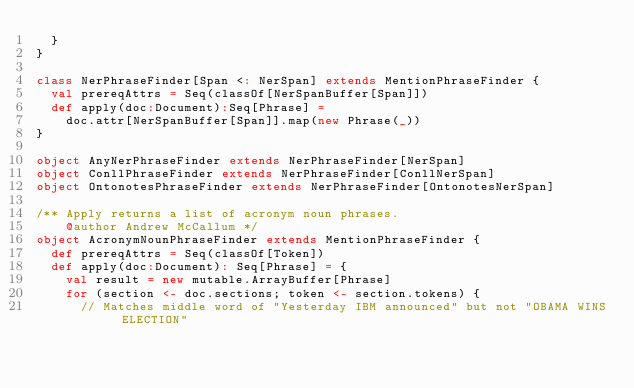<code> <loc_0><loc_0><loc_500><loc_500><_Scala_>  }
}

class NerPhraseFinder[Span <: NerSpan] extends MentionPhraseFinder {
  val prereqAttrs = Seq(classOf[NerSpanBuffer[Span]])
  def apply(doc:Document):Seq[Phrase] =
    doc.attr[NerSpanBuffer[Span]].map(new Phrase(_))
}

object AnyNerPhraseFinder extends NerPhraseFinder[NerSpan]
object ConllPhraseFinder extends NerPhraseFinder[ConllNerSpan]
object OntonotesPhraseFinder extends NerPhraseFinder[OntonotesNerSpan]

/** Apply returns a list of acronym noun phrases.
    @author Andrew McCallum */
object AcronymNounPhraseFinder extends MentionPhraseFinder {
  def prereqAttrs = Seq(classOf[Token])
  def apply(doc:Document): Seq[Phrase] = {
    val result = new mutable.ArrayBuffer[Phrase]
    for (section <- doc.sections; token <- section.tokens) {
      // Matches middle word of "Yesterday IBM announced" but not "OBAMA WINS ELECTION"</code> 